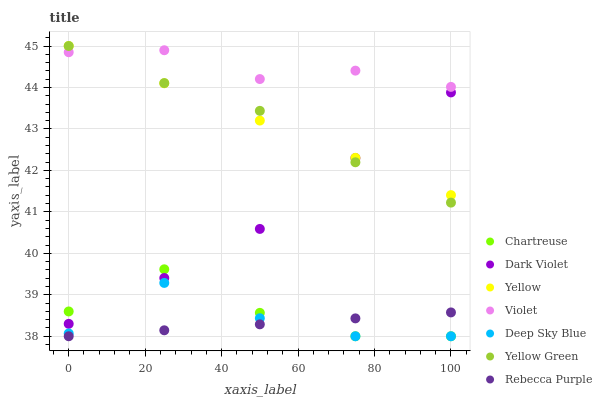Does Rebecca Purple have the minimum area under the curve?
Answer yes or no. Yes. Does Violet have the maximum area under the curve?
Answer yes or no. Yes. Does Yellow have the minimum area under the curve?
Answer yes or no. No. Does Yellow have the maximum area under the curve?
Answer yes or no. No. Is Rebecca Purple the smoothest?
Answer yes or no. Yes. Is Chartreuse the roughest?
Answer yes or no. Yes. Is Yellow the smoothest?
Answer yes or no. No. Is Yellow the roughest?
Answer yes or no. No. Does Chartreuse have the lowest value?
Answer yes or no. Yes. Does Yellow have the lowest value?
Answer yes or no. No. Does Yellow have the highest value?
Answer yes or no. Yes. Does Chartreuse have the highest value?
Answer yes or no. No. Is Chartreuse less than Yellow Green?
Answer yes or no. Yes. Is Violet greater than Chartreuse?
Answer yes or no. Yes. Does Dark Violet intersect Yellow Green?
Answer yes or no. Yes. Is Dark Violet less than Yellow Green?
Answer yes or no. No. Is Dark Violet greater than Yellow Green?
Answer yes or no. No. Does Chartreuse intersect Yellow Green?
Answer yes or no. No. 